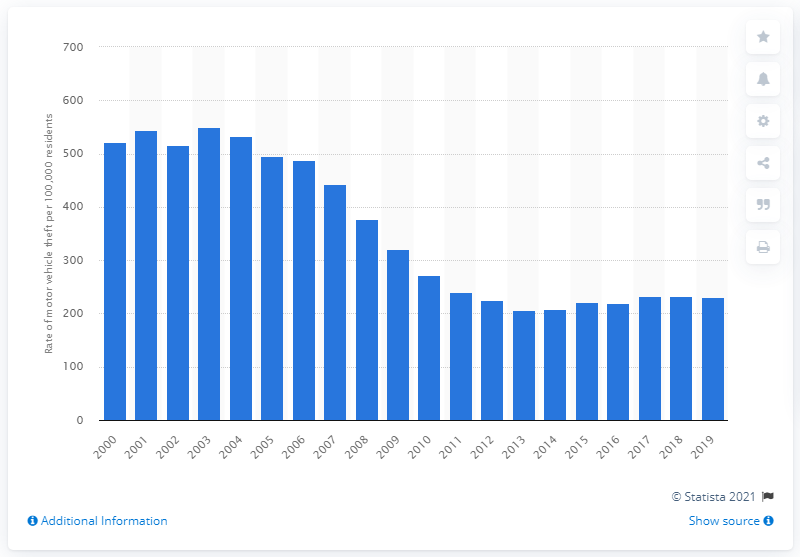Identify some key points in this picture. In 2019, there were an estimated 231.62 motor vehicle thefts reported per 100,000 residents in Canada. 